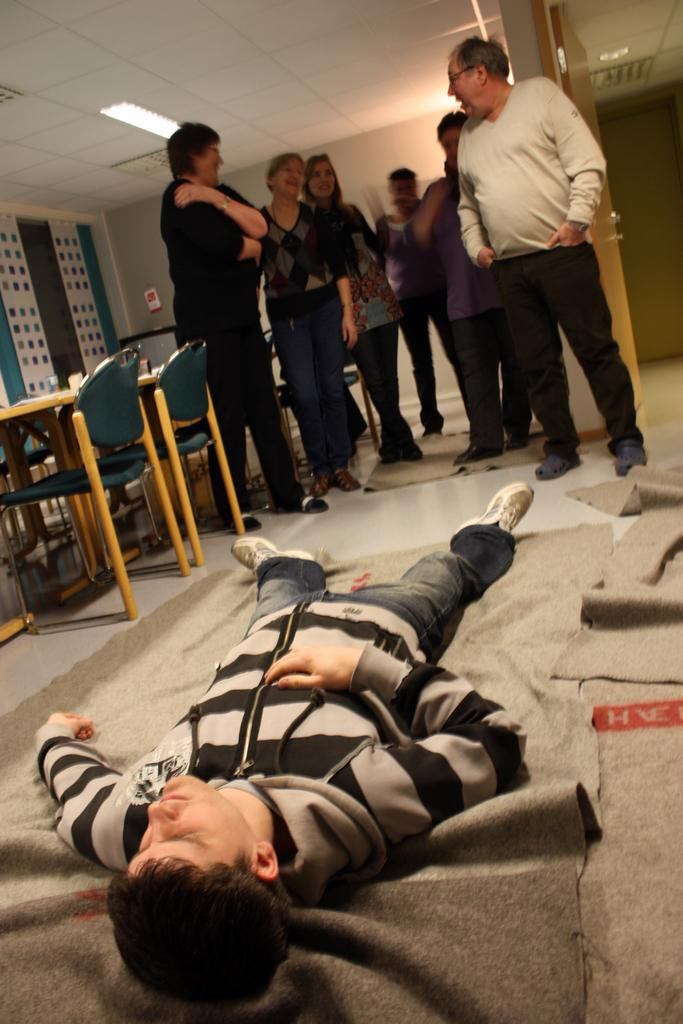How many people are in the image? There is a group of people in the image. What is the position of one person in the group? One person is lying on the floor. What type of furniture is present in the image? There are chairs and tables in the image. What can be seen providing illumination in the image? There are lights in the image. Can you see a hill in the background of the image? There is no hill visible in the image. What type of hen is sitting on the table in the image? There is no hen present in the image. 